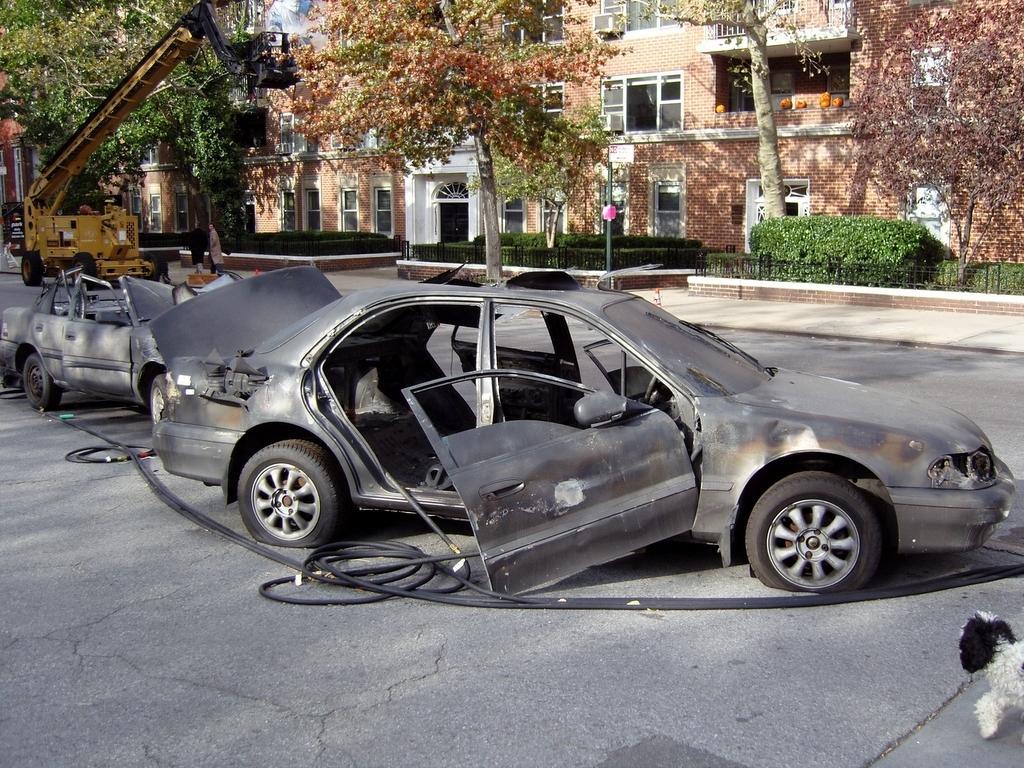Can you describe this image briefly? In this image I can see few vehicles on the road. I can also see a dog which is in black and white color, background I can see trees in green and brown color, and buildings in brown color and the sky is in blue and white color. 